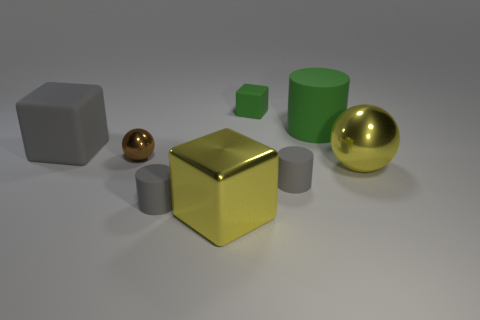Subtract 1 cubes. How many cubes are left? 2 Add 2 large purple blocks. How many objects exist? 10 Subtract all spheres. How many objects are left? 6 Add 6 tiny gray cylinders. How many tiny gray cylinders exist? 8 Subtract 1 yellow spheres. How many objects are left? 7 Subtract all big rubber blocks. Subtract all gray objects. How many objects are left? 4 Add 3 gray rubber blocks. How many gray rubber blocks are left? 4 